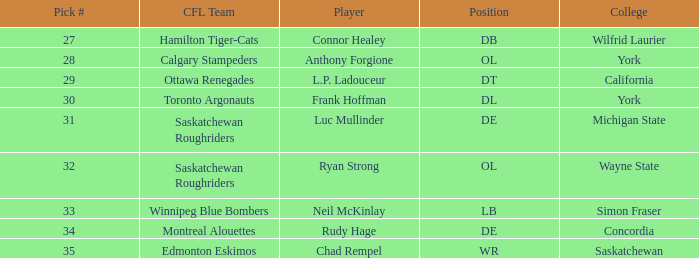What is the Pick # for Ryan Strong? 32.0. 